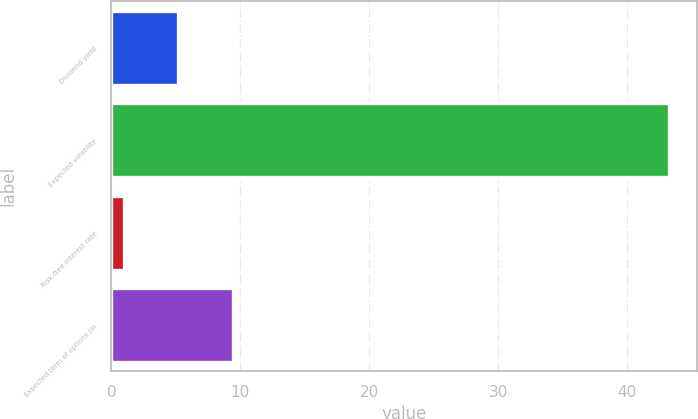Convert chart. <chart><loc_0><loc_0><loc_500><loc_500><bar_chart><fcel>Dividend yield<fcel>Expected volatility<fcel>Risk-free interest rate<fcel>Expected term of options (in<nl><fcel>5.18<fcel>43.28<fcel>0.95<fcel>9.41<nl></chart> 